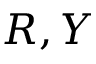<formula> <loc_0><loc_0><loc_500><loc_500>R , Y</formula> 